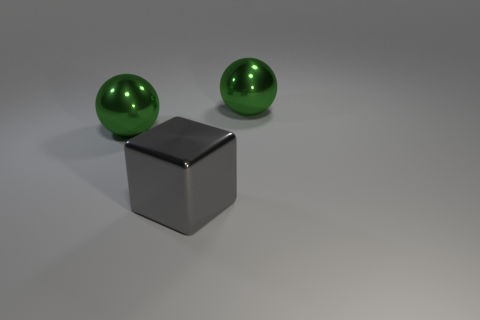How many green balls must be subtracted to get 1 green balls? 1 Add 3 metallic objects. How many objects exist? 6 Add 3 green shiny spheres. How many green shiny spheres are left? 5 Add 2 large things. How many large things exist? 5 Subtract 0 yellow balls. How many objects are left? 3 Subtract all spheres. How many objects are left? 1 Subtract all metallic blocks. Subtract all big gray things. How many objects are left? 1 